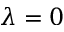<formula> <loc_0><loc_0><loc_500><loc_500>\lambda = 0</formula> 